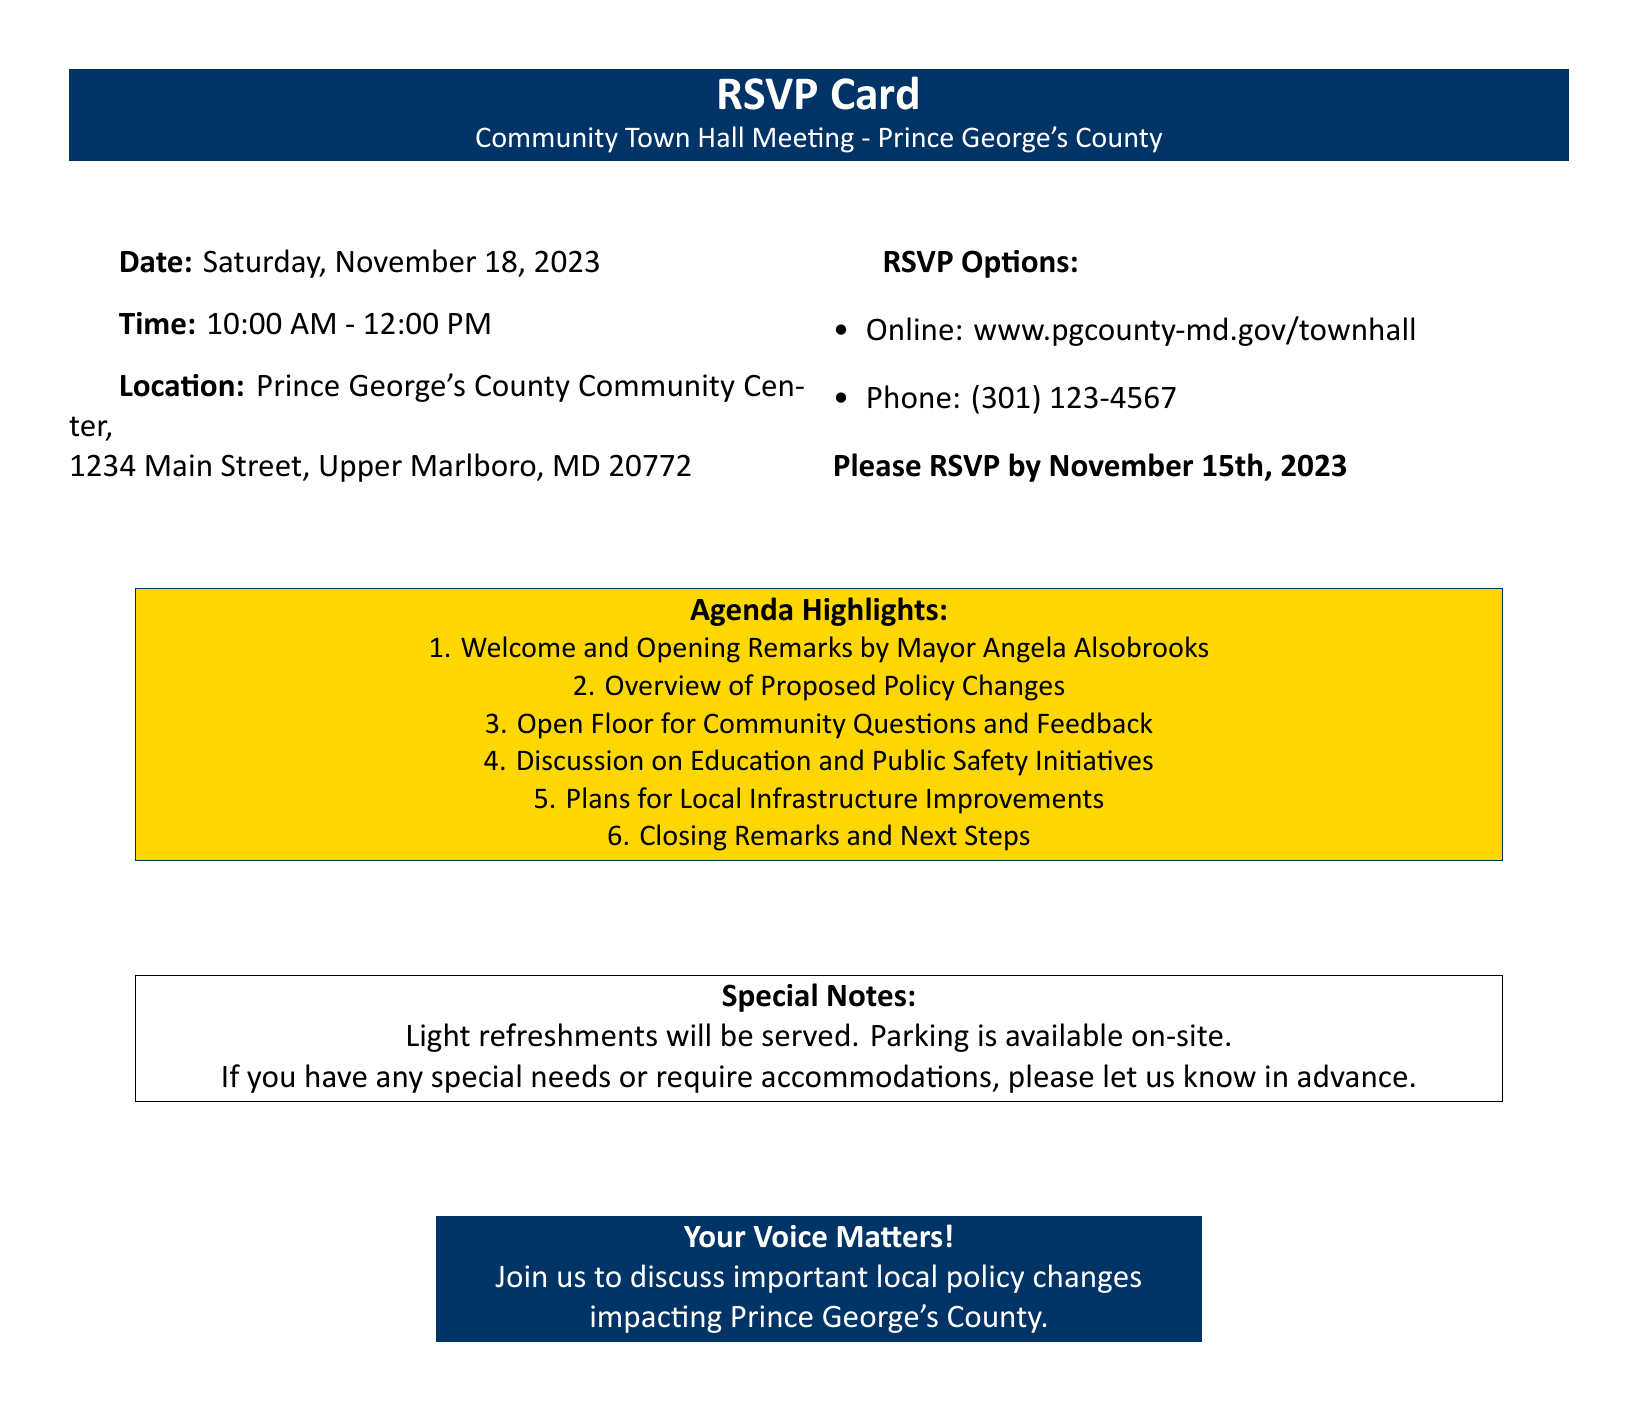What is the date of the meeting? The date of the meeting is specified in the document under the "Date" section.
Answer: Saturday, November 18, 2023 What time does the meeting start? The meeting start time is listed under the "Time" section in the document.
Answer: 10:00 AM Where is the location of the town hall meeting? The location is mentioned in the "Location" section of the document.
Answer: Prince George's County Community Center, 1234 Main Street, Upper Marlboro, MD 20772 What is the RSVP deadline? The RSVP deadline is noted in the "RSVP Options" section of the document.
Answer: November 15th, 2023 Who will give the opening remarks? The person giving the opening remarks is mentioned in the "Agenda Highlights" section.
Answer: Mayor Angela Alsobrooks What is one of the topics for discussion during the meeting? The topics for discussion can be found in the "Agenda Highlights" section; a specific example is required.
Answer: Education and Public Safety Initiatives What will be served at the meeting? The special notes section states what will be available during the meeting.
Answer: Light refreshments What is one way to RSVP for the meeting? The document mentions multiple RSVP options, including how to RSVP online or by phone.
Answer: Online: www.pgcounty-md.gov/townhall Is parking available on-site? The availability of parking is clearly noted in the "Special Notes" section.
Answer: Yes What is the purpose of the town hall meeting? The purpose is stated in the closing remarks of the document, highlighting community involvement.
Answer: Important local policy changes impacting Prince George's County 